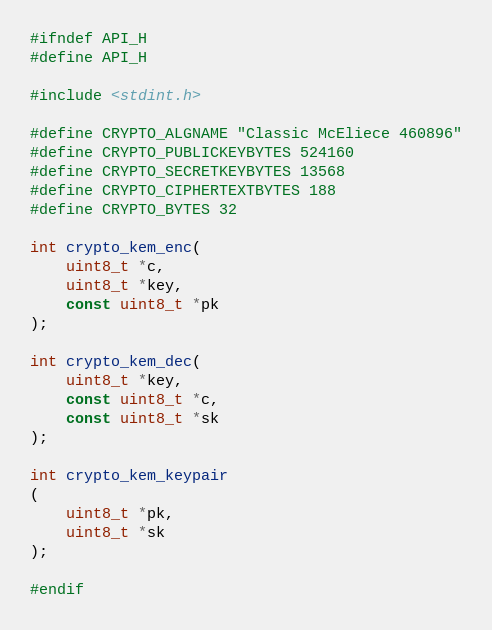<code> <loc_0><loc_0><loc_500><loc_500><_C_>#ifndef API_H
#define API_H

#include <stdint.h>

#define CRYPTO_ALGNAME "Classic McEliece 460896"
#define CRYPTO_PUBLICKEYBYTES 524160
#define CRYPTO_SECRETKEYBYTES 13568
#define CRYPTO_CIPHERTEXTBYTES 188
#define CRYPTO_BYTES 32

int crypto_kem_enc(
    uint8_t *c,
    uint8_t *key,
    const uint8_t *pk
);

int crypto_kem_dec(
    uint8_t *key,
    const uint8_t *c,
    const uint8_t *sk
);

int crypto_kem_keypair
(
    uint8_t *pk,
    uint8_t *sk
);

#endif

</code> 